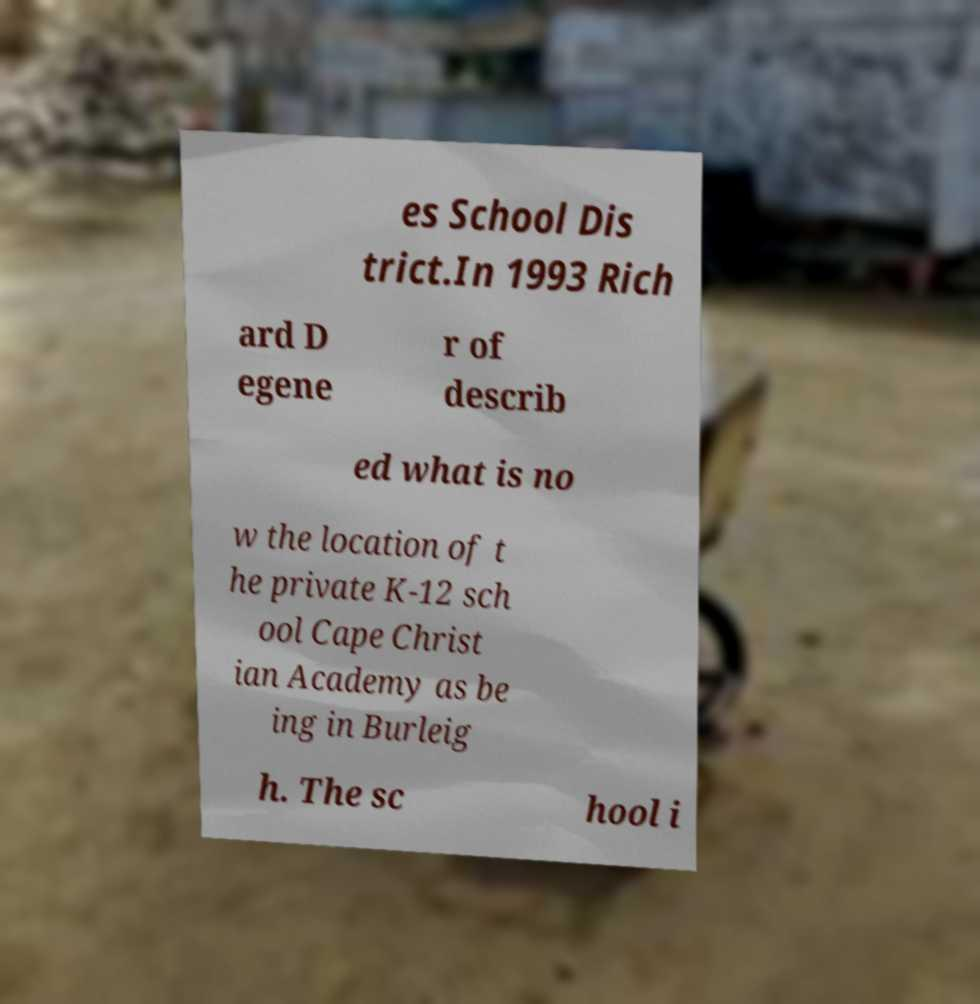Please read and relay the text visible in this image. What does it say? es School Dis trict.In 1993 Rich ard D egene r of describ ed what is no w the location of t he private K-12 sch ool Cape Christ ian Academy as be ing in Burleig h. The sc hool i 